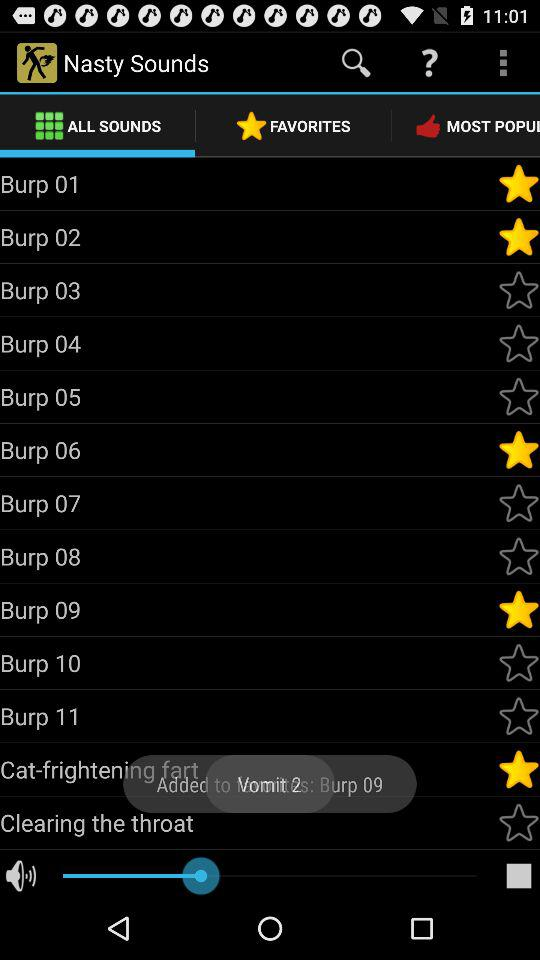What is the app name? The app name is "Nasty Sounds". 